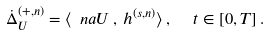Convert formula to latex. <formula><loc_0><loc_0><loc_500><loc_500>\dot { \Delta } ^ { ( + , n ) } _ { U } = \langle \ n a U \, , \, h ^ { ( s , n ) } \rangle \, , \, \ \ t \in [ 0 , T ] \, .</formula> 